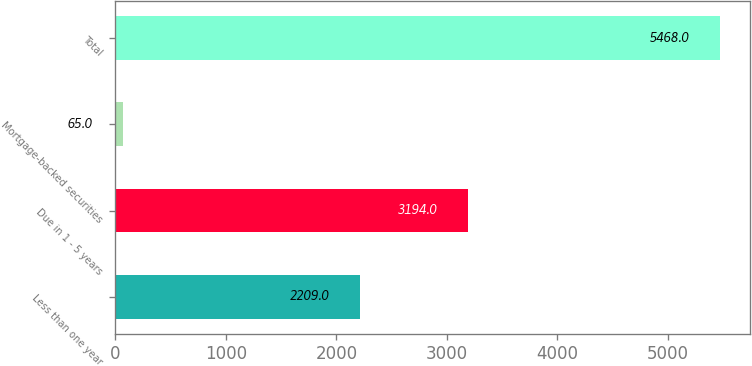Convert chart. <chart><loc_0><loc_0><loc_500><loc_500><bar_chart><fcel>Less than one year<fcel>Due in 1 - 5 years<fcel>Mortgage-backed securities<fcel>Total<nl><fcel>2209<fcel>3194<fcel>65<fcel>5468<nl></chart> 